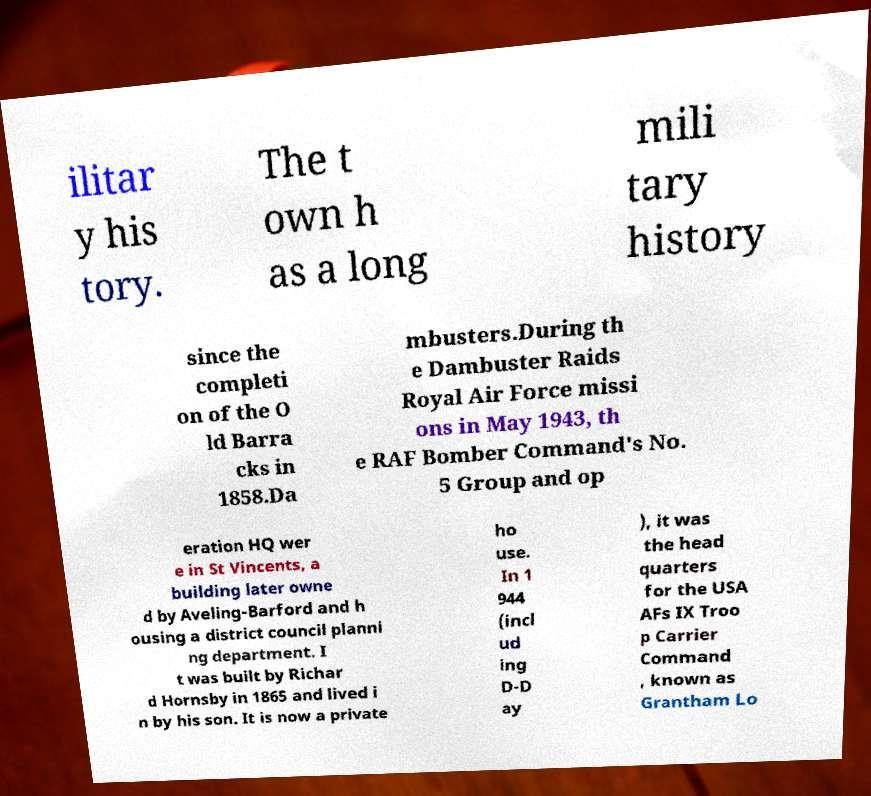Please identify and transcribe the text found in this image. ilitar y his tory. The t own h as a long mili tary history since the completi on of the O ld Barra cks in 1858.Da mbusters.During th e Dambuster Raids Royal Air Force missi ons in May 1943, th e RAF Bomber Command's No. 5 Group and op eration HQ wer e in St Vincents, a building later owne d by Aveling-Barford and h ousing a district council planni ng department. I t was built by Richar d Hornsby in 1865 and lived i n by his son. It is now a private ho use. In 1 944 (incl ud ing D-D ay ), it was the head quarters for the USA AFs IX Troo p Carrier Command , known as Grantham Lo 